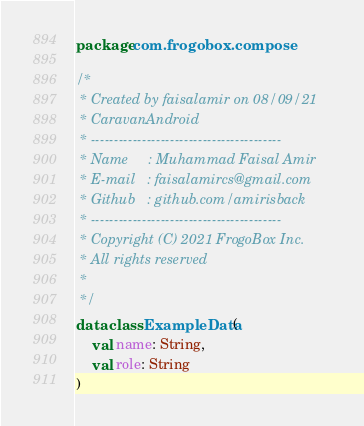Convert code to text. <code><loc_0><loc_0><loc_500><loc_500><_Kotlin_>package com.frogobox.compose

/*
 * Created by faisalamir on 08/09/21
 * CaravanAndroid
 * -----------------------------------------
 * Name     : Muhammad Faisal Amir
 * E-mail   : faisalamircs@gmail.com
 * Github   : github.com/amirisback
 * -----------------------------------------
 * Copyright (C) 2021 FrogoBox Inc.      
 * All rights reserved
 *
 */
data class ExampleData(
    val name: String,
    val role: String
)</code> 